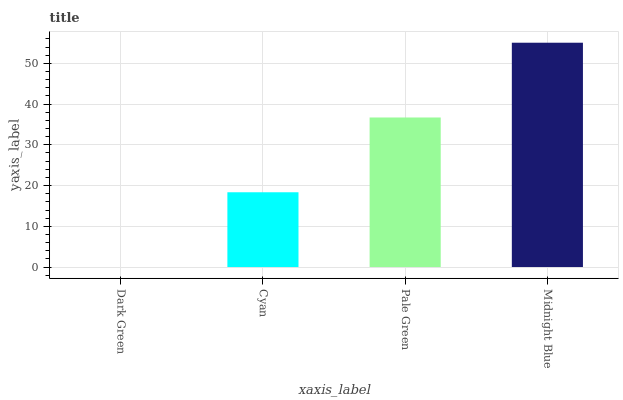Is Dark Green the minimum?
Answer yes or no. Yes. Is Midnight Blue the maximum?
Answer yes or no. Yes. Is Cyan the minimum?
Answer yes or no. No. Is Cyan the maximum?
Answer yes or no. No. Is Cyan greater than Dark Green?
Answer yes or no. Yes. Is Dark Green less than Cyan?
Answer yes or no. Yes. Is Dark Green greater than Cyan?
Answer yes or no. No. Is Cyan less than Dark Green?
Answer yes or no. No. Is Pale Green the high median?
Answer yes or no. Yes. Is Cyan the low median?
Answer yes or no. Yes. Is Cyan the high median?
Answer yes or no. No. Is Midnight Blue the low median?
Answer yes or no. No. 